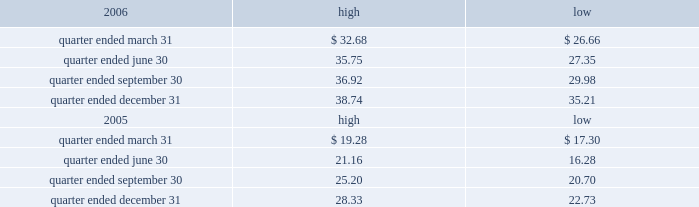Part ii item 5 .
Market for registrant 2019s common equity , related stockholder matters and issuer purchases of equity securities the table presents reported quarterly high and low per share sale prices of our class a common stock on the new york stock exchange ( nyse ) for the years 2006 and 2005. .
On february 22 , 2007 , the closing price of our class a common stock was $ 40.38 per share as reported on the nyse .
As of february 22 , 2007 , we had 419988395 outstanding shares of class a common stock and 623 registered holders .
In february 2004 , all outstanding shares of our class b common stock were converted into shares of our class a common stock on a one-for-one basis pursuant to the occurrence of the 201cdodge conversion event 201d as defined in our charter .
Also in february 2004 , all outstanding shares of class c common stock were converted into shares of class a common stock on a one-for-one basis .
In august 2005 , we amended and restated our charter to , among other things , eliminate our class b common stock and class c common stock .
Dividends we have never paid a dividend on any class of our common stock .
We anticipate that we may retain future earnings , if any , to fund the development and growth of our business .
The indentures governing our 7.50% ( 7.50 % ) senior notes due 2012 ( 7.50% ( 7.50 % ) notes ) and our 7.125% ( 7.125 % ) senior notes due 2012 ( 7.125% ( 7.125 % ) notes ) may prohibit us from paying dividends to our stockholders unless we satisfy certain financial covenants .
Our credit facilities and the indentures governing the terms of our debt securities contain covenants that may restrict the ability of our subsidiaries from making to us any direct or indirect distribution , dividend or other payment on account of their limited liability company interests , partnership interests , capital stock or other equity interests .
Under our credit facilities , the borrower subsidiaries may pay cash dividends or make other distributions to us in accordance with the applicable credit facility only if no default exists or would be created thereby .
The indenture governing the terms of the ati 7.25% ( 7.25 % ) notes prohibit ati and certain of our other subsidiaries that have guaranteed those notes ( sister guarantors ) from paying dividends and making other payments or distributions to us unless certain financial covenants are satisfied .
The indentures governing the terms of our 7.50% ( 7.50 % ) notes and 7.125% ( 7.125 % ) notes also contain certain restrictive covenants , which prohibit the restricted subsidiaries under these indentures from paying dividends and making other payments or distributions to us unless certain financial covenants are satisfied .
For more information about the restrictions under our credit facilities and our notes indentures , see item 7 of this annual report under the caption 201cmanagement 2019s discussion and analysis of financial condition and results of operations 2014liquidity and capital resources 2014factors affecting sources of liquidity 201d and note 7 to our consolidated financial statements included in this annual report. .
What is the growth rate in the price of shares from the highest value during the quarter ended december 31 , 2006 and the closing price on february 22 , 2007? 
Computations: ((40.38 - 38.74) / 38.74)
Answer: 0.04233. Part ii item 5 .
Market for registrant 2019s common equity , related stockholder matters and issuer purchases of equity securities the table presents reported quarterly high and low per share sale prices of our class a common stock on the new york stock exchange ( nyse ) for the years 2006 and 2005. .
On february 22 , 2007 , the closing price of our class a common stock was $ 40.38 per share as reported on the nyse .
As of february 22 , 2007 , we had 419988395 outstanding shares of class a common stock and 623 registered holders .
In february 2004 , all outstanding shares of our class b common stock were converted into shares of our class a common stock on a one-for-one basis pursuant to the occurrence of the 201cdodge conversion event 201d as defined in our charter .
Also in february 2004 , all outstanding shares of class c common stock were converted into shares of class a common stock on a one-for-one basis .
In august 2005 , we amended and restated our charter to , among other things , eliminate our class b common stock and class c common stock .
Dividends we have never paid a dividend on any class of our common stock .
We anticipate that we may retain future earnings , if any , to fund the development and growth of our business .
The indentures governing our 7.50% ( 7.50 % ) senior notes due 2012 ( 7.50% ( 7.50 % ) notes ) and our 7.125% ( 7.125 % ) senior notes due 2012 ( 7.125% ( 7.125 % ) notes ) may prohibit us from paying dividends to our stockholders unless we satisfy certain financial covenants .
Our credit facilities and the indentures governing the terms of our debt securities contain covenants that may restrict the ability of our subsidiaries from making to us any direct or indirect distribution , dividend or other payment on account of their limited liability company interests , partnership interests , capital stock or other equity interests .
Under our credit facilities , the borrower subsidiaries may pay cash dividends or make other distributions to us in accordance with the applicable credit facility only if no default exists or would be created thereby .
The indenture governing the terms of the ati 7.25% ( 7.25 % ) notes prohibit ati and certain of our other subsidiaries that have guaranteed those notes ( sister guarantors ) from paying dividends and making other payments or distributions to us unless certain financial covenants are satisfied .
The indentures governing the terms of our 7.50% ( 7.50 % ) notes and 7.125% ( 7.125 % ) notes also contain certain restrictive covenants , which prohibit the restricted subsidiaries under these indentures from paying dividends and making other payments or distributions to us unless certain financial covenants are satisfied .
For more information about the restrictions under our credit facilities and our notes indentures , see item 7 of this annual report under the caption 201cmanagement 2019s discussion and analysis of financial condition and results of operations 2014liquidity and capital resources 2014factors affecting sources of liquidity 201d and note 7 to our consolidated financial statements included in this annual report. .
For the quarter ended december 312006 what was the percent of the change in share price? 
Computations: ((38.74 / 35.21) / 35.21)
Answer: 0.03125. 